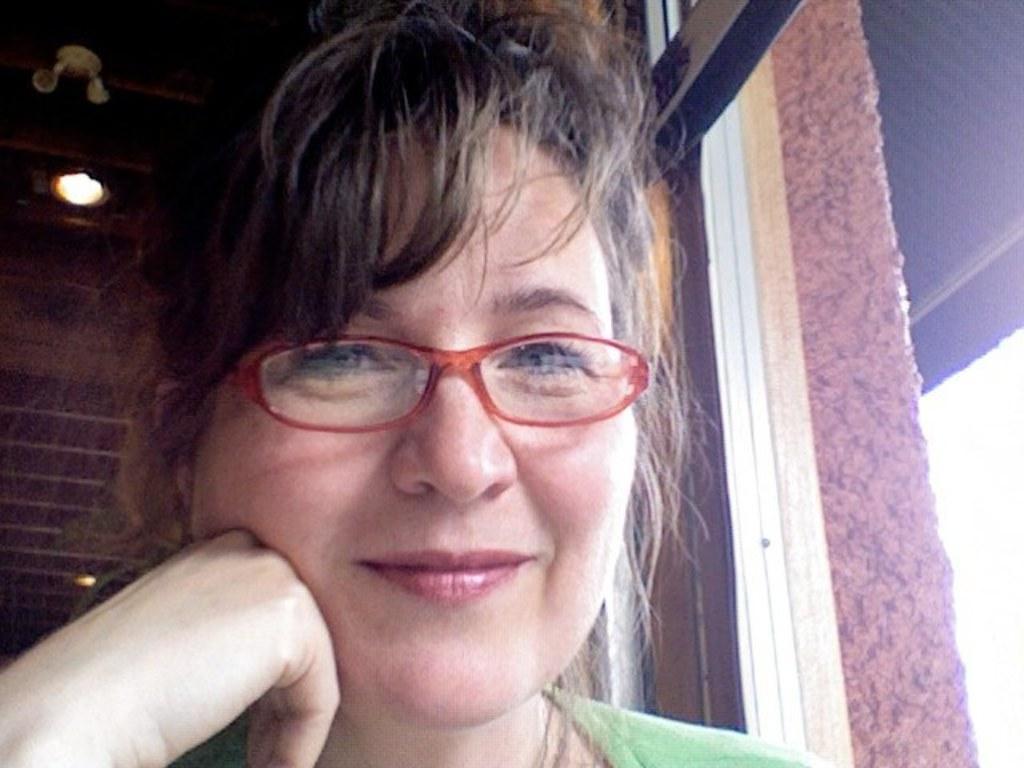Can you describe this image briefly? In this image in the foreground there is one woman who is smiling, and she is wearing spectacles. And on the right side there is a window, and in the background there is light and some objects. 